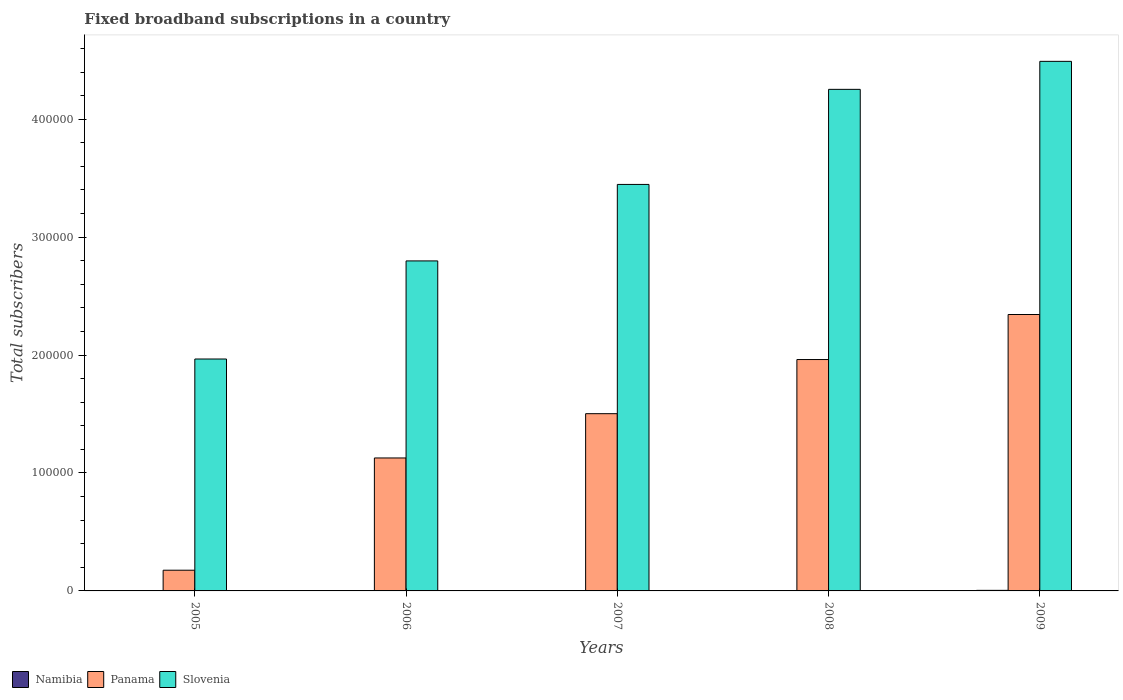Are the number of bars on each tick of the X-axis equal?
Provide a succinct answer. Yes. How many bars are there on the 3rd tick from the left?
Your answer should be compact. 3. How many bars are there on the 1st tick from the right?
Make the answer very short. 3. What is the label of the 5th group of bars from the left?
Offer a very short reply. 2009. In how many cases, is the number of bars for a given year not equal to the number of legend labels?
Offer a terse response. 0. What is the number of broadband subscriptions in Namibia in 2006?
Offer a terse response. 198. Across all years, what is the maximum number of broadband subscriptions in Slovenia?
Your response must be concise. 4.49e+05. Across all years, what is the minimum number of broadband subscriptions in Namibia?
Offer a very short reply. 134. In which year was the number of broadband subscriptions in Namibia maximum?
Offer a terse response. 2009. What is the total number of broadband subscriptions in Slovenia in the graph?
Offer a very short reply. 1.70e+06. What is the difference between the number of broadband subscriptions in Slovenia in 2005 and that in 2008?
Keep it short and to the point. -2.29e+05. What is the difference between the number of broadband subscriptions in Namibia in 2007 and the number of broadband subscriptions in Panama in 2006?
Provide a short and direct response. -1.12e+05. What is the average number of broadband subscriptions in Panama per year?
Provide a short and direct response. 1.42e+05. In the year 2009, what is the difference between the number of broadband subscriptions in Panama and number of broadband subscriptions in Namibia?
Ensure brevity in your answer.  2.34e+05. What is the ratio of the number of broadband subscriptions in Slovenia in 2007 to that in 2008?
Your answer should be compact. 0.81. Is the number of broadband subscriptions in Slovenia in 2005 less than that in 2008?
Provide a succinct answer. Yes. What is the difference between the highest and the second highest number of broadband subscriptions in Namibia?
Ensure brevity in your answer.  157. What is the difference between the highest and the lowest number of broadband subscriptions in Namibia?
Give a very brief answer. 343. What does the 1st bar from the left in 2009 represents?
Provide a succinct answer. Namibia. What does the 3rd bar from the right in 2007 represents?
Give a very brief answer. Namibia. How many bars are there?
Provide a succinct answer. 15. Are all the bars in the graph horizontal?
Provide a short and direct response. No. How many years are there in the graph?
Ensure brevity in your answer.  5. Does the graph contain any zero values?
Your answer should be very brief. No. How are the legend labels stacked?
Ensure brevity in your answer.  Horizontal. What is the title of the graph?
Your answer should be very brief. Fixed broadband subscriptions in a country. What is the label or title of the Y-axis?
Your answer should be very brief. Total subscribers. What is the Total subscribers of Namibia in 2005?
Ensure brevity in your answer.  134. What is the Total subscribers in Panama in 2005?
Offer a very short reply. 1.76e+04. What is the Total subscribers of Slovenia in 2005?
Offer a very short reply. 1.97e+05. What is the Total subscribers of Namibia in 2006?
Give a very brief answer. 198. What is the Total subscribers in Panama in 2006?
Your response must be concise. 1.13e+05. What is the Total subscribers of Slovenia in 2006?
Keep it short and to the point. 2.80e+05. What is the Total subscribers in Namibia in 2007?
Your answer should be very brief. 256. What is the Total subscribers in Panama in 2007?
Give a very brief answer. 1.50e+05. What is the Total subscribers of Slovenia in 2007?
Your answer should be compact. 3.45e+05. What is the Total subscribers of Namibia in 2008?
Keep it short and to the point. 320. What is the Total subscribers of Panama in 2008?
Your answer should be very brief. 1.96e+05. What is the Total subscribers of Slovenia in 2008?
Your response must be concise. 4.25e+05. What is the Total subscribers in Namibia in 2009?
Offer a terse response. 477. What is the Total subscribers of Panama in 2009?
Make the answer very short. 2.34e+05. What is the Total subscribers in Slovenia in 2009?
Give a very brief answer. 4.49e+05. Across all years, what is the maximum Total subscribers in Namibia?
Provide a short and direct response. 477. Across all years, what is the maximum Total subscribers of Panama?
Offer a very short reply. 2.34e+05. Across all years, what is the maximum Total subscribers in Slovenia?
Offer a terse response. 4.49e+05. Across all years, what is the minimum Total subscribers in Namibia?
Provide a short and direct response. 134. Across all years, what is the minimum Total subscribers of Panama?
Ensure brevity in your answer.  1.76e+04. Across all years, what is the minimum Total subscribers of Slovenia?
Your response must be concise. 1.97e+05. What is the total Total subscribers of Namibia in the graph?
Your response must be concise. 1385. What is the total Total subscribers of Panama in the graph?
Your response must be concise. 7.11e+05. What is the total Total subscribers in Slovenia in the graph?
Give a very brief answer. 1.70e+06. What is the difference between the Total subscribers in Namibia in 2005 and that in 2006?
Provide a short and direct response. -64. What is the difference between the Total subscribers of Panama in 2005 and that in 2006?
Keep it short and to the point. -9.52e+04. What is the difference between the Total subscribers of Slovenia in 2005 and that in 2006?
Give a very brief answer. -8.32e+04. What is the difference between the Total subscribers in Namibia in 2005 and that in 2007?
Offer a very short reply. -122. What is the difference between the Total subscribers in Panama in 2005 and that in 2007?
Your answer should be very brief. -1.33e+05. What is the difference between the Total subscribers of Slovenia in 2005 and that in 2007?
Your answer should be very brief. -1.48e+05. What is the difference between the Total subscribers of Namibia in 2005 and that in 2008?
Provide a succinct answer. -186. What is the difference between the Total subscribers of Panama in 2005 and that in 2008?
Keep it short and to the point. -1.79e+05. What is the difference between the Total subscribers of Slovenia in 2005 and that in 2008?
Provide a succinct answer. -2.29e+05. What is the difference between the Total subscribers of Namibia in 2005 and that in 2009?
Offer a terse response. -343. What is the difference between the Total subscribers in Panama in 2005 and that in 2009?
Provide a succinct answer. -2.17e+05. What is the difference between the Total subscribers of Slovenia in 2005 and that in 2009?
Offer a terse response. -2.52e+05. What is the difference between the Total subscribers in Namibia in 2006 and that in 2007?
Give a very brief answer. -58. What is the difference between the Total subscribers in Panama in 2006 and that in 2007?
Give a very brief answer. -3.75e+04. What is the difference between the Total subscribers of Slovenia in 2006 and that in 2007?
Your answer should be compact. -6.49e+04. What is the difference between the Total subscribers of Namibia in 2006 and that in 2008?
Ensure brevity in your answer.  -122. What is the difference between the Total subscribers in Panama in 2006 and that in 2008?
Your answer should be compact. -8.35e+04. What is the difference between the Total subscribers in Slovenia in 2006 and that in 2008?
Your response must be concise. -1.45e+05. What is the difference between the Total subscribers of Namibia in 2006 and that in 2009?
Your answer should be very brief. -279. What is the difference between the Total subscribers in Panama in 2006 and that in 2009?
Provide a short and direct response. -1.22e+05. What is the difference between the Total subscribers of Slovenia in 2006 and that in 2009?
Your response must be concise. -1.69e+05. What is the difference between the Total subscribers of Namibia in 2007 and that in 2008?
Your answer should be very brief. -64. What is the difference between the Total subscribers in Panama in 2007 and that in 2008?
Give a very brief answer. -4.59e+04. What is the difference between the Total subscribers of Slovenia in 2007 and that in 2008?
Offer a terse response. -8.06e+04. What is the difference between the Total subscribers of Namibia in 2007 and that in 2009?
Make the answer very short. -221. What is the difference between the Total subscribers of Panama in 2007 and that in 2009?
Make the answer very short. -8.41e+04. What is the difference between the Total subscribers of Slovenia in 2007 and that in 2009?
Make the answer very short. -1.04e+05. What is the difference between the Total subscribers of Namibia in 2008 and that in 2009?
Your response must be concise. -157. What is the difference between the Total subscribers of Panama in 2008 and that in 2009?
Provide a succinct answer. -3.82e+04. What is the difference between the Total subscribers of Slovenia in 2008 and that in 2009?
Ensure brevity in your answer.  -2.37e+04. What is the difference between the Total subscribers in Namibia in 2005 and the Total subscribers in Panama in 2006?
Provide a succinct answer. -1.13e+05. What is the difference between the Total subscribers in Namibia in 2005 and the Total subscribers in Slovenia in 2006?
Keep it short and to the point. -2.80e+05. What is the difference between the Total subscribers of Panama in 2005 and the Total subscribers of Slovenia in 2006?
Offer a terse response. -2.62e+05. What is the difference between the Total subscribers in Namibia in 2005 and the Total subscribers in Panama in 2007?
Provide a short and direct response. -1.50e+05. What is the difference between the Total subscribers in Namibia in 2005 and the Total subscribers in Slovenia in 2007?
Offer a very short reply. -3.45e+05. What is the difference between the Total subscribers in Panama in 2005 and the Total subscribers in Slovenia in 2007?
Make the answer very short. -3.27e+05. What is the difference between the Total subscribers in Namibia in 2005 and the Total subscribers in Panama in 2008?
Provide a succinct answer. -1.96e+05. What is the difference between the Total subscribers of Namibia in 2005 and the Total subscribers of Slovenia in 2008?
Keep it short and to the point. -4.25e+05. What is the difference between the Total subscribers of Panama in 2005 and the Total subscribers of Slovenia in 2008?
Your answer should be very brief. -4.08e+05. What is the difference between the Total subscribers of Namibia in 2005 and the Total subscribers of Panama in 2009?
Offer a terse response. -2.34e+05. What is the difference between the Total subscribers of Namibia in 2005 and the Total subscribers of Slovenia in 2009?
Offer a terse response. -4.49e+05. What is the difference between the Total subscribers in Panama in 2005 and the Total subscribers in Slovenia in 2009?
Your response must be concise. -4.31e+05. What is the difference between the Total subscribers of Namibia in 2006 and the Total subscribers of Panama in 2007?
Your response must be concise. -1.50e+05. What is the difference between the Total subscribers in Namibia in 2006 and the Total subscribers in Slovenia in 2007?
Your answer should be very brief. -3.44e+05. What is the difference between the Total subscribers of Panama in 2006 and the Total subscribers of Slovenia in 2007?
Offer a terse response. -2.32e+05. What is the difference between the Total subscribers in Namibia in 2006 and the Total subscribers in Panama in 2008?
Your response must be concise. -1.96e+05. What is the difference between the Total subscribers in Namibia in 2006 and the Total subscribers in Slovenia in 2008?
Provide a succinct answer. -4.25e+05. What is the difference between the Total subscribers in Panama in 2006 and the Total subscribers in Slovenia in 2008?
Make the answer very short. -3.13e+05. What is the difference between the Total subscribers of Namibia in 2006 and the Total subscribers of Panama in 2009?
Your response must be concise. -2.34e+05. What is the difference between the Total subscribers in Namibia in 2006 and the Total subscribers in Slovenia in 2009?
Offer a terse response. -4.49e+05. What is the difference between the Total subscribers in Panama in 2006 and the Total subscribers in Slovenia in 2009?
Give a very brief answer. -3.36e+05. What is the difference between the Total subscribers in Namibia in 2007 and the Total subscribers in Panama in 2008?
Provide a short and direct response. -1.96e+05. What is the difference between the Total subscribers of Namibia in 2007 and the Total subscribers of Slovenia in 2008?
Your answer should be compact. -4.25e+05. What is the difference between the Total subscribers in Panama in 2007 and the Total subscribers in Slovenia in 2008?
Give a very brief answer. -2.75e+05. What is the difference between the Total subscribers in Namibia in 2007 and the Total subscribers in Panama in 2009?
Provide a short and direct response. -2.34e+05. What is the difference between the Total subscribers in Namibia in 2007 and the Total subscribers in Slovenia in 2009?
Give a very brief answer. -4.49e+05. What is the difference between the Total subscribers of Panama in 2007 and the Total subscribers of Slovenia in 2009?
Your answer should be compact. -2.99e+05. What is the difference between the Total subscribers of Namibia in 2008 and the Total subscribers of Panama in 2009?
Keep it short and to the point. -2.34e+05. What is the difference between the Total subscribers of Namibia in 2008 and the Total subscribers of Slovenia in 2009?
Offer a terse response. -4.49e+05. What is the difference between the Total subscribers of Panama in 2008 and the Total subscribers of Slovenia in 2009?
Ensure brevity in your answer.  -2.53e+05. What is the average Total subscribers of Namibia per year?
Keep it short and to the point. 277. What is the average Total subscribers of Panama per year?
Offer a very short reply. 1.42e+05. What is the average Total subscribers in Slovenia per year?
Give a very brief answer. 3.39e+05. In the year 2005, what is the difference between the Total subscribers of Namibia and Total subscribers of Panama?
Provide a short and direct response. -1.74e+04. In the year 2005, what is the difference between the Total subscribers of Namibia and Total subscribers of Slovenia?
Make the answer very short. -1.97e+05. In the year 2005, what is the difference between the Total subscribers in Panama and Total subscribers in Slovenia?
Make the answer very short. -1.79e+05. In the year 2006, what is the difference between the Total subscribers in Namibia and Total subscribers in Panama?
Make the answer very short. -1.13e+05. In the year 2006, what is the difference between the Total subscribers in Namibia and Total subscribers in Slovenia?
Your answer should be compact. -2.80e+05. In the year 2006, what is the difference between the Total subscribers in Panama and Total subscribers in Slovenia?
Your answer should be compact. -1.67e+05. In the year 2007, what is the difference between the Total subscribers of Namibia and Total subscribers of Panama?
Your answer should be very brief. -1.50e+05. In the year 2007, what is the difference between the Total subscribers in Namibia and Total subscribers in Slovenia?
Give a very brief answer. -3.44e+05. In the year 2007, what is the difference between the Total subscribers in Panama and Total subscribers in Slovenia?
Make the answer very short. -1.94e+05. In the year 2008, what is the difference between the Total subscribers in Namibia and Total subscribers in Panama?
Keep it short and to the point. -1.96e+05. In the year 2008, what is the difference between the Total subscribers in Namibia and Total subscribers in Slovenia?
Offer a terse response. -4.25e+05. In the year 2008, what is the difference between the Total subscribers of Panama and Total subscribers of Slovenia?
Provide a succinct answer. -2.29e+05. In the year 2009, what is the difference between the Total subscribers of Namibia and Total subscribers of Panama?
Provide a short and direct response. -2.34e+05. In the year 2009, what is the difference between the Total subscribers in Namibia and Total subscribers in Slovenia?
Offer a very short reply. -4.49e+05. In the year 2009, what is the difference between the Total subscribers of Panama and Total subscribers of Slovenia?
Your answer should be very brief. -2.15e+05. What is the ratio of the Total subscribers in Namibia in 2005 to that in 2006?
Provide a short and direct response. 0.68. What is the ratio of the Total subscribers in Panama in 2005 to that in 2006?
Offer a terse response. 0.16. What is the ratio of the Total subscribers of Slovenia in 2005 to that in 2006?
Provide a succinct answer. 0.7. What is the ratio of the Total subscribers in Namibia in 2005 to that in 2007?
Offer a very short reply. 0.52. What is the ratio of the Total subscribers of Panama in 2005 to that in 2007?
Give a very brief answer. 0.12. What is the ratio of the Total subscribers in Slovenia in 2005 to that in 2007?
Give a very brief answer. 0.57. What is the ratio of the Total subscribers in Namibia in 2005 to that in 2008?
Provide a short and direct response. 0.42. What is the ratio of the Total subscribers in Panama in 2005 to that in 2008?
Provide a succinct answer. 0.09. What is the ratio of the Total subscribers of Slovenia in 2005 to that in 2008?
Offer a terse response. 0.46. What is the ratio of the Total subscribers of Namibia in 2005 to that in 2009?
Offer a very short reply. 0.28. What is the ratio of the Total subscribers in Panama in 2005 to that in 2009?
Give a very brief answer. 0.07. What is the ratio of the Total subscribers of Slovenia in 2005 to that in 2009?
Ensure brevity in your answer.  0.44. What is the ratio of the Total subscribers of Namibia in 2006 to that in 2007?
Ensure brevity in your answer.  0.77. What is the ratio of the Total subscribers of Panama in 2006 to that in 2007?
Provide a succinct answer. 0.75. What is the ratio of the Total subscribers in Slovenia in 2006 to that in 2007?
Your answer should be very brief. 0.81. What is the ratio of the Total subscribers of Namibia in 2006 to that in 2008?
Provide a short and direct response. 0.62. What is the ratio of the Total subscribers in Panama in 2006 to that in 2008?
Make the answer very short. 0.57. What is the ratio of the Total subscribers in Slovenia in 2006 to that in 2008?
Your response must be concise. 0.66. What is the ratio of the Total subscribers of Namibia in 2006 to that in 2009?
Ensure brevity in your answer.  0.42. What is the ratio of the Total subscribers of Panama in 2006 to that in 2009?
Your response must be concise. 0.48. What is the ratio of the Total subscribers of Slovenia in 2006 to that in 2009?
Ensure brevity in your answer.  0.62. What is the ratio of the Total subscribers in Panama in 2007 to that in 2008?
Keep it short and to the point. 0.77. What is the ratio of the Total subscribers in Slovenia in 2007 to that in 2008?
Provide a short and direct response. 0.81. What is the ratio of the Total subscribers of Namibia in 2007 to that in 2009?
Provide a succinct answer. 0.54. What is the ratio of the Total subscribers in Panama in 2007 to that in 2009?
Your response must be concise. 0.64. What is the ratio of the Total subscribers of Slovenia in 2007 to that in 2009?
Offer a very short reply. 0.77. What is the ratio of the Total subscribers of Namibia in 2008 to that in 2009?
Your answer should be very brief. 0.67. What is the ratio of the Total subscribers in Panama in 2008 to that in 2009?
Your response must be concise. 0.84. What is the ratio of the Total subscribers in Slovenia in 2008 to that in 2009?
Give a very brief answer. 0.95. What is the difference between the highest and the second highest Total subscribers in Namibia?
Provide a short and direct response. 157. What is the difference between the highest and the second highest Total subscribers of Panama?
Keep it short and to the point. 3.82e+04. What is the difference between the highest and the second highest Total subscribers in Slovenia?
Offer a very short reply. 2.37e+04. What is the difference between the highest and the lowest Total subscribers of Namibia?
Offer a terse response. 343. What is the difference between the highest and the lowest Total subscribers in Panama?
Make the answer very short. 2.17e+05. What is the difference between the highest and the lowest Total subscribers of Slovenia?
Your response must be concise. 2.52e+05. 